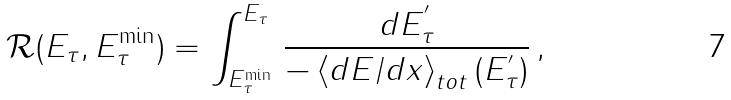Convert formula to latex. <formula><loc_0><loc_0><loc_500><loc_500>\mathcal { R } ( E _ { \tau } , E _ { \tau } ^ { \min } ) = \int _ { E _ { \tau } ^ { \min } } ^ { E _ { \tau } } \, \frac { d E ^ { ^ { \prime } } _ { \tau } } { - \left \langle d E / d x \right \rangle _ { t o t } ( E ^ { ^ { \prime } } _ { \tau } ) } \, ,</formula> 